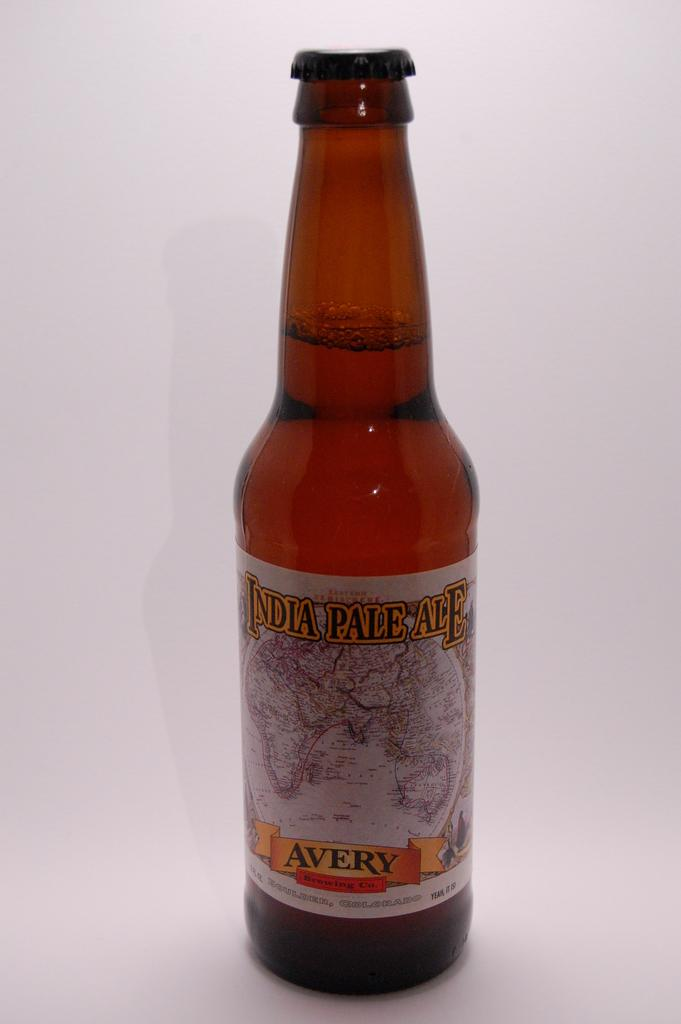<image>
Write a terse but informative summary of the picture. A bottle of India Pale Ale is from Avery Brewing Co. 